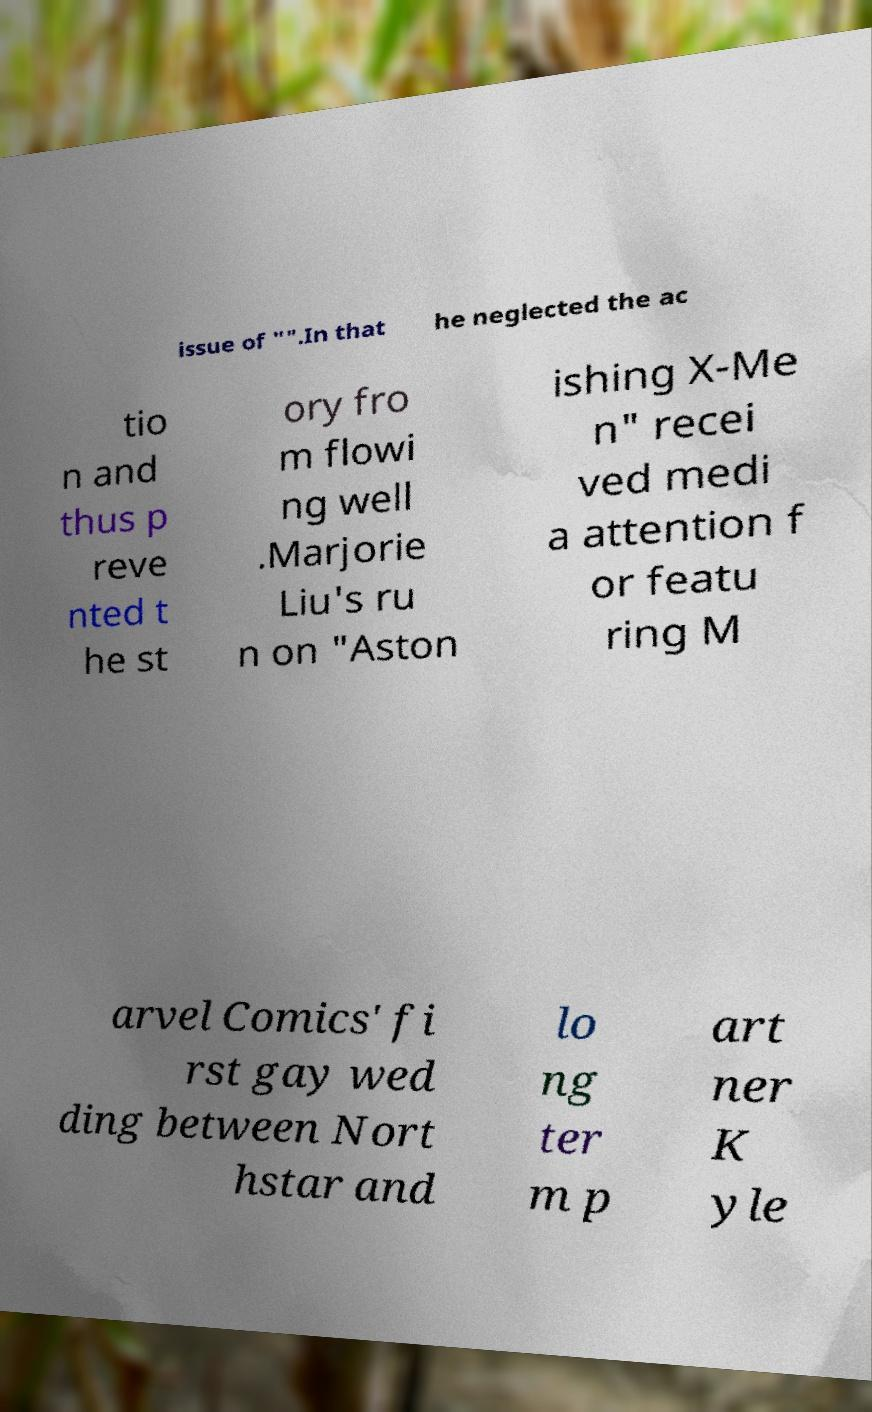For documentation purposes, I need the text within this image transcribed. Could you provide that? issue of "".In that he neglected the ac tio n and thus p reve nted t he st ory fro m flowi ng well .Marjorie Liu's ru n on "Aston ishing X-Me n" recei ved medi a attention f or featu ring M arvel Comics' fi rst gay wed ding between Nort hstar and lo ng ter m p art ner K yle 